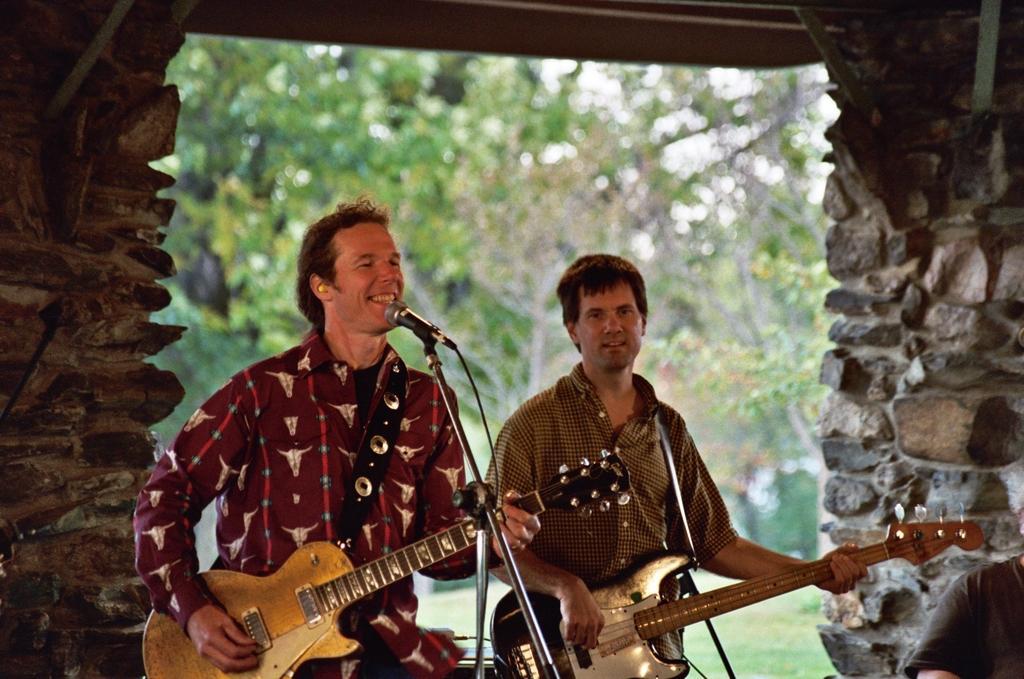In one or two sentences, can you explain what this image depicts? In this image i can see two persons holding a guitar and singing in front of a micro phone, at the back ground i can see a wall,a tree and a sky. 